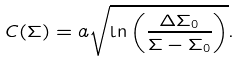<formula> <loc_0><loc_0><loc_500><loc_500>C ( \Sigma ) = a \sqrt { \ln \left ( \frac { \Delta \Sigma _ { 0 } } { \Sigma - \Sigma _ { 0 } } \right ) } .</formula> 